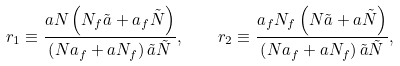<formula> <loc_0><loc_0><loc_500><loc_500>r _ { 1 } \equiv \frac { a N \left ( N _ { f } \tilde { a } + a _ { f } \tilde { N } \right ) } { \left ( N a _ { f } + a N _ { f } \right ) \tilde { a } \tilde { N } } , \quad r _ { 2 } \equiv \frac { a _ { f } N _ { f } \left ( N \tilde { a } + a \tilde { N } \right ) } { \left ( N a _ { f } + a N _ { f } \right ) \tilde { a } \tilde { N } } ,</formula> 